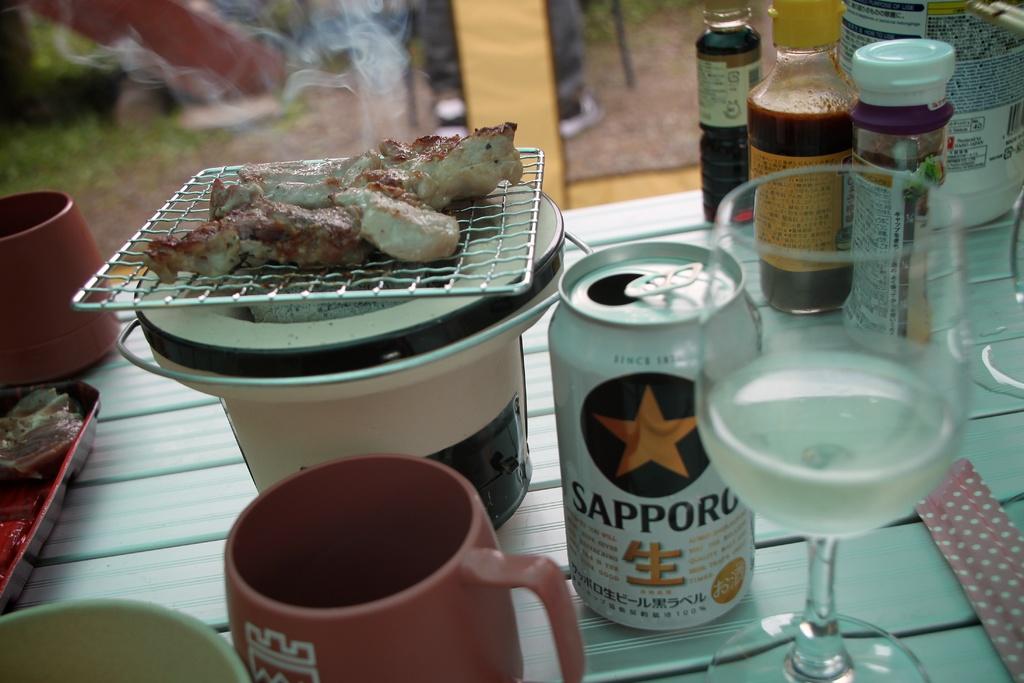What type of beverage is inside the can?
Offer a very short reply. Sapporo. What is the name of the beer?
Make the answer very short. Sapporo. 